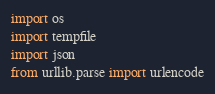<code> <loc_0><loc_0><loc_500><loc_500><_Python_>import os
import tempfile
import json
from urllib.parse import urlencode

</code> 